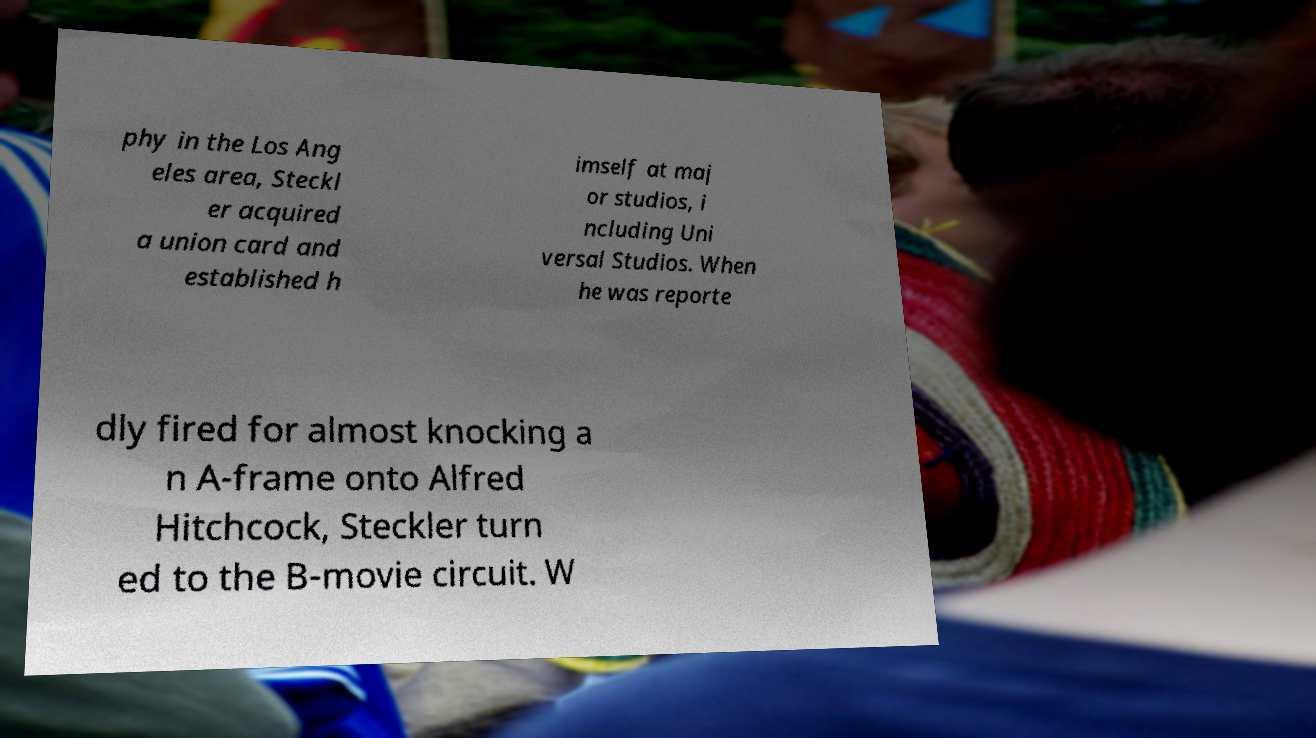Could you extract and type out the text from this image? phy in the Los Ang eles area, Steckl er acquired a union card and established h imself at maj or studios, i ncluding Uni versal Studios. When he was reporte dly fired for almost knocking a n A-frame onto Alfred Hitchcock, Steckler turn ed to the B-movie circuit. W 